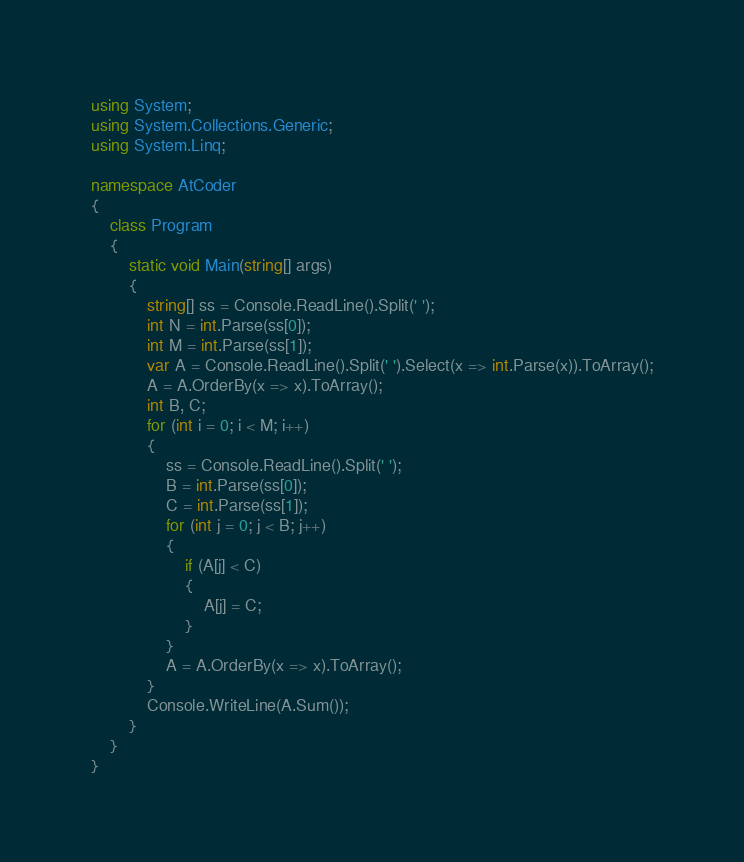Convert code to text. <code><loc_0><loc_0><loc_500><loc_500><_C#_>using System;
using System.Collections.Generic;
using System.Linq;

namespace AtCoder
{
    class Program
    {
        static void Main(string[] args)
        {
            string[] ss = Console.ReadLine().Split(' ');
            int N = int.Parse(ss[0]);
            int M = int.Parse(ss[1]);
            var A = Console.ReadLine().Split(' ').Select(x => int.Parse(x)).ToArray();
            A = A.OrderBy(x => x).ToArray();
            int B, C;
            for (int i = 0; i < M; i++)
            {
                ss = Console.ReadLine().Split(' ');
                B = int.Parse(ss[0]);
                C = int.Parse(ss[1]);
                for (int j = 0; j < B; j++)
                {
                    if (A[j] < C)
                    {
                        A[j] = C;
                    }
                }
                A = A.OrderBy(x => x).ToArray();
            }
            Console.WriteLine(A.Sum());
        }
    }
}
</code> 